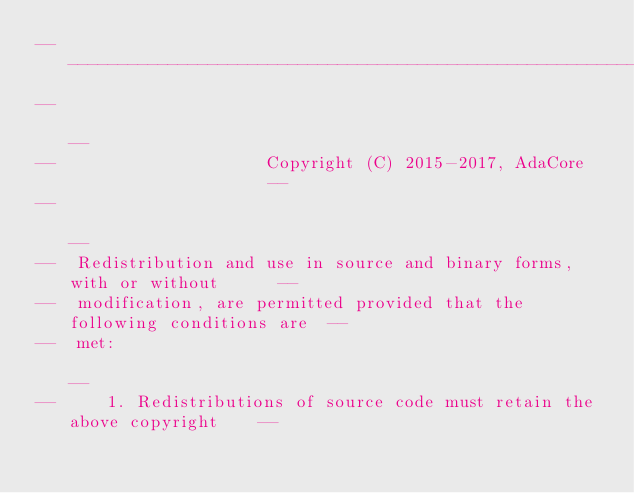Convert code to text. <code><loc_0><loc_0><loc_500><loc_500><_Ada_>------------------------------------------------------------------------------
--                                                                          --
--                     Copyright (C) 2015-2017, AdaCore                     --
--                                                                          --
--  Redistribution and use in source and binary forms, with or without      --
--  modification, are permitted provided that the following conditions are  --
--  met:                                                                    --
--     1. Redistributions of source code must retain the above copyright    --</code> 